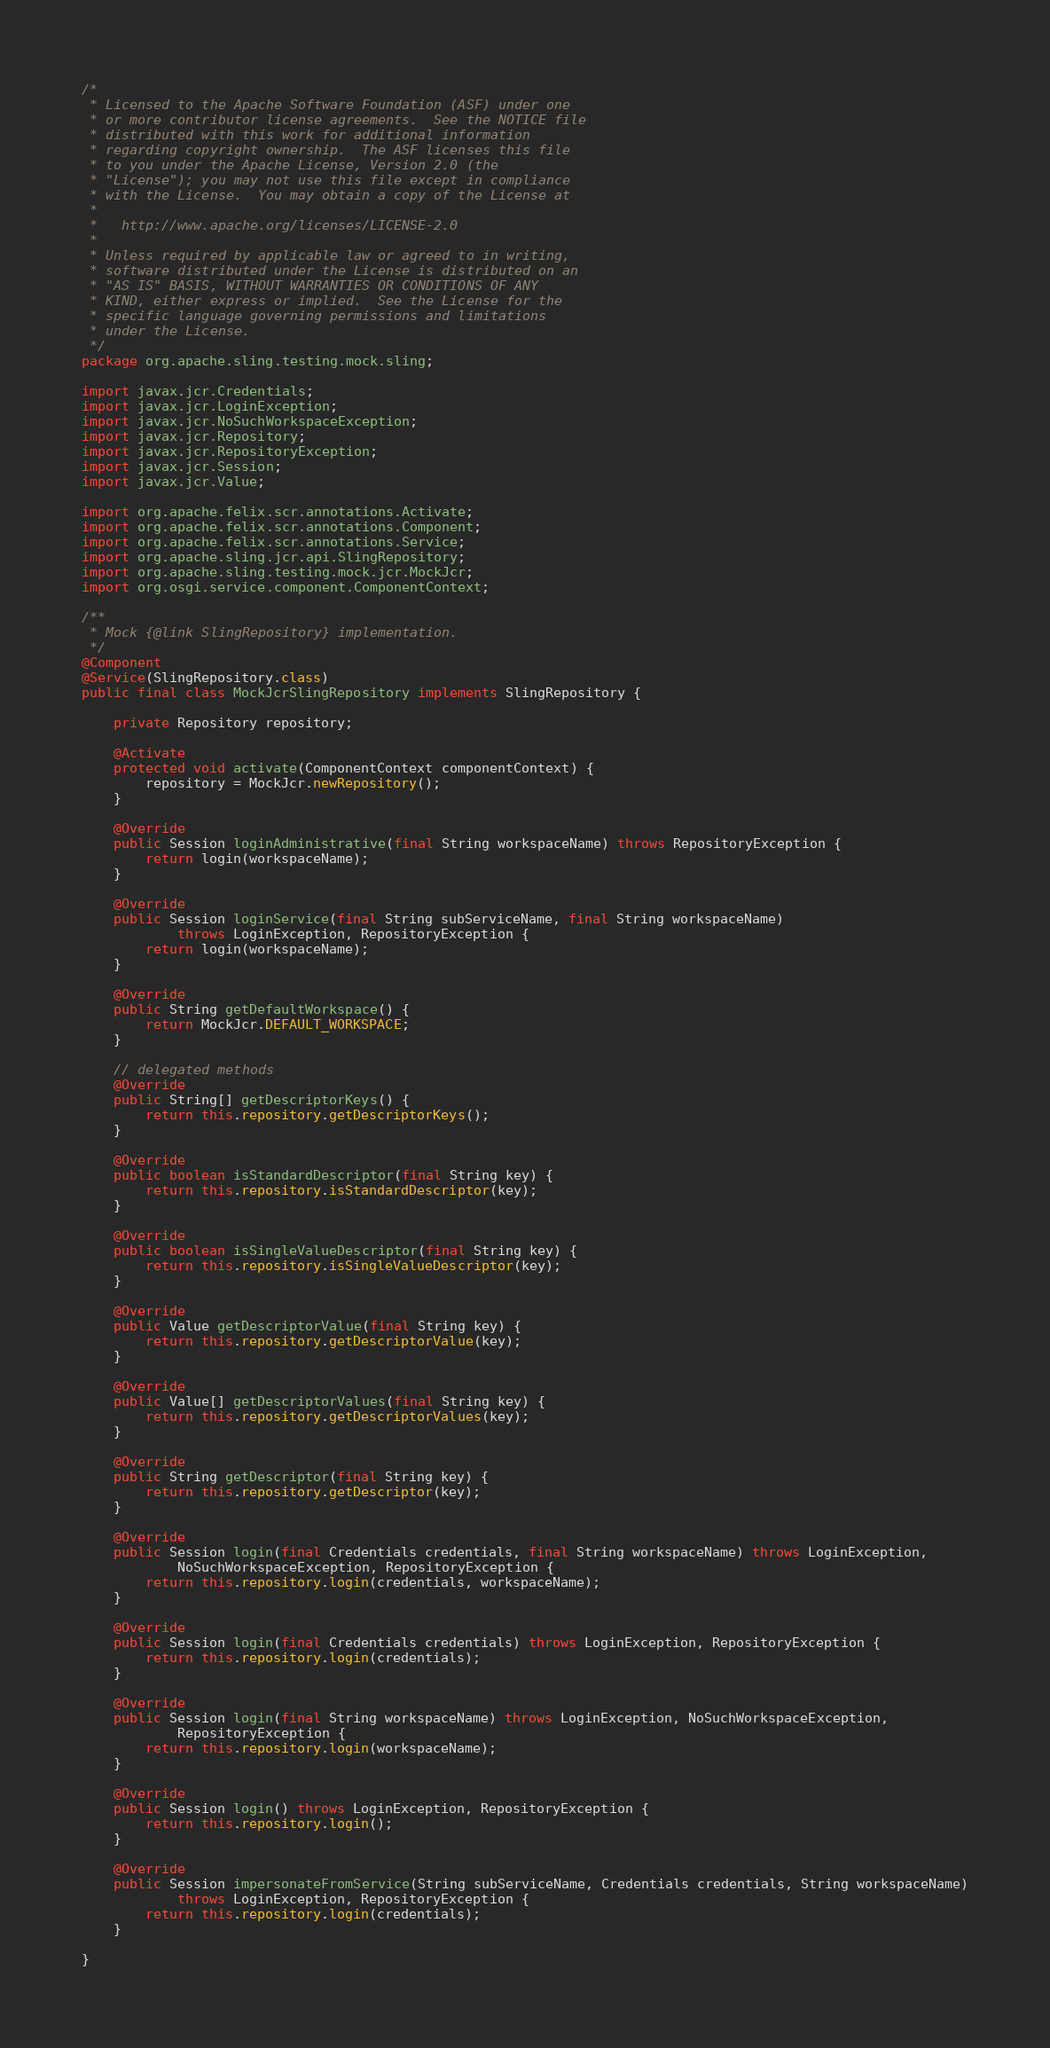Convert code to text. <code><loc_0><loc_0><loc_500><loc_500><_Java_>/*
 * Licensed to the Apache Software Foundation (ASF) under one
 * or more contributor license agreements.  See the NOTICE file
 * distributed with this work for additional information
 * regarding copyright ownership.  The ASF licenses this file
 * to you under the Apache License, Version 2.0 (the
 * "License"); you may not use this file except in compliance
 * with the License.  You may obtain a copy of the License at
 *
 *   http://www.apache.org/licenses/LICENSE-2.0
 *
 * Unless required by applicable law or agreed to in writing,
 * software distributed under the License is distributed on an
 * "AS IS" BASIS, WITHOUT WARRANTIES OR CONDITIONS OF ANY
 * KIND, either express or implied.  See the License for the
 * specific language governing permissions and limitations
 * under the License.
 */
package org.apache.sling.testing.mock.sling;

import javax.jcr.Credentials;
import javax.jcr.LoginException;
import javax.jcr.NoSuchWorkspaceException;
import javax.jcr.Repository;
import javax.jcr.RepositoryException;
import javax.jcr.Session;
import javax.jcr.Value;

import org.apache.felix.scr.annotations.Activate;
import org.apache.felix.scr.annotations.Component;
import org.apache.felix.scr.annotations.Service;
import org.apache.sling.jcr.api.SlingRepository;
import org.apache.sling.testing.mock.jcr.MockJcr;
import org.osgi.service.component.ComponentContext;

/**
 * Mock {@link SlingRepository} implementation.
 */
@Component
@Service(SlingRepository.class)
public final class MockJcrSlingRepository implements SlingRepository {

    private Repository repository;
    
    @Activate
    protected void activate(ComponentContext componentContext) {
        repository = MockJcr.newRepository();
    }

    @Override
    public Session loginAdministrative(final String workspaceName) throws RepositoryException {
        return login(workspaceName);
    }

    @Override
    public Session loginService(final String subServiceName, final String workspaceName)
            throws LoginException, RepositoryException {
        return login(workspaceName);
    }

    @Override
    public String getDefaultWorkspace() {
        return MockJcr.DEFAULT_WORKSPACE;
    }

    // delegated methods
    @Override
    public String[] getDescriptorKeys() {
        return this.repository.getDescriptorKeys();
    }

    @Override
    public boolean isStandardDescriptor(final String key) {
        return this.repository.isStandardDescriptor(key);
    }

    @Override
    public boolean isSingleValueDescriptor(final String key) {
        return this.repository.isSingleValueDescriptor(key);
    }

    @Override
    public Value getDescriptorValue(final String key) {
        return this.repository.getDescriptorValue(key);
    }

    @Override
    public Value[] getDescriptorValues(final String key) {
        return this.repository.getDescriptorValues(key);
    }

    @Override
    public String getDescriptor(final String key) {
        return this.repository.getDescriptor(key);
    }

    @Override
    public Session login(final Credentials credentials, final String workspaceName) throws LoginException,
            NoSuchWorkspaceException, RepositoryException {
        return this.repository.login(credentials, workspaceName);
    }

    @Override
    public Session login(final Credentials credentials) throws LoginException, RepositoryException {
        return this.repository.login(credentials);
    }

    @Override
    public Session login(final String workspaceName) throws LoginException, NoSuchWorkspaceException,
            RepositoryException {
        return this.repository.login(workspaceName);
    }

    @Override
    public Session login() throws LoginException, RepositoryException {
        return this.repository.login();
    }

    @Override
    public Session impersonateFromService(String subServiceName, Credentials credentials, String workspaceName)
            throws LoginException, RepositoryException {
        return this.repository.login(credentials);
    }

}
</code> 